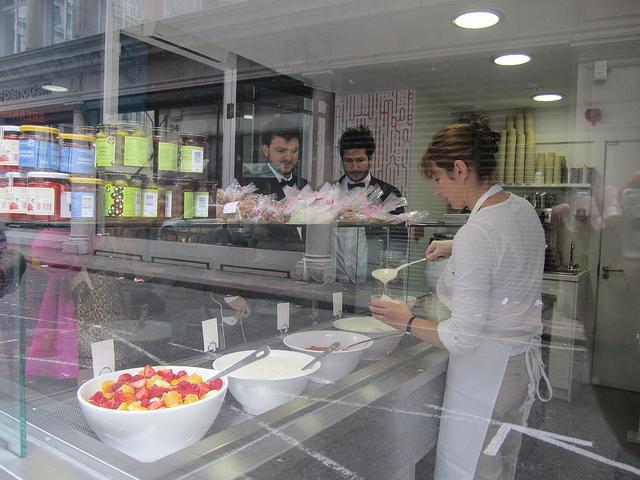What is the color of the woman's apron?
Be succinct. White. What colored aprons are the people wearing?
Short answer required. White. What kind of print is on the uniform pants?
Keep it brief. None. Is anyone wearing tuxedo's?
Give a very brief answer. Yes. How many human hands are shown?
Give a very brief answer. 2. What is in the big bowl on the left?
Concise answer only. Fruit. Does this parlor have warm colors?
Give a very brief answer. No. Is the cook a woman?
Quick response, please. Yes. What does this restaurant sell?
Keep it brief. Food. 